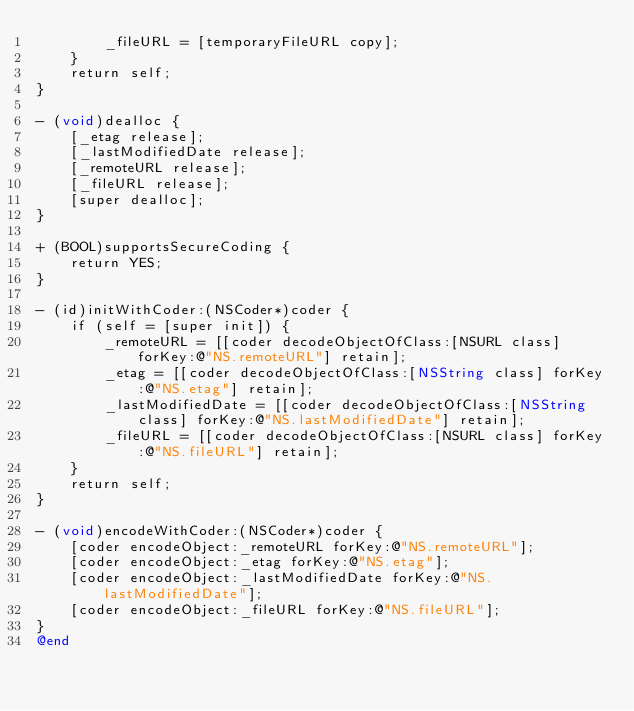<code> <loc_0><loc_0><loc_500><loc_500><_ObjectiveC_>        _fileURL = [temporaryFileURL copy];
    }
    return self;
}

- (void)dealloc {
    [_etag release];
    [_lastModifiedDate release];
    [_remoteURL release];
    [_fileURL release];
    [super dealloc];
}

+ (BOOL)supportsSecureCoding {
    return YES;
}

- (id)initWithCoder:(NSCoder*)coder {
    if (self = [super init]) {
        _remoteURL = [[coder decodeObjectOfClass:[NSURL class] forKey:@"NS.remoteURL"] retain];
        _etag = [[coder decodeObjectOfClass:[NSString class] forKey:@"NS.etag"] retain];
        _lastModifiedDate = [[coder decodeObjectOfClass:[NSString class] forKey:@"NS.lastModifiedDate"] retain];
        _fileURL = [[coder decodeObjectOfClass:[NSURL class] forKey:@"NS.fileURL"] retain];
    }
    return self;
}

- (void)encodeWithCoder:(NSCoder*)coder {
    [coder encodeObject:_remoteURL forKey:@"NS.remoteURL"];
    [coder encodeObject:_etag forKey:@"NS.etag"];
    [coder encodeObject:_lastModifiedDate forKey:@"NS.lastModifiedDate"];
    [coder encodeObject:_fileURL forKey:@"NS.fileURL"];
}
@end

</code> 